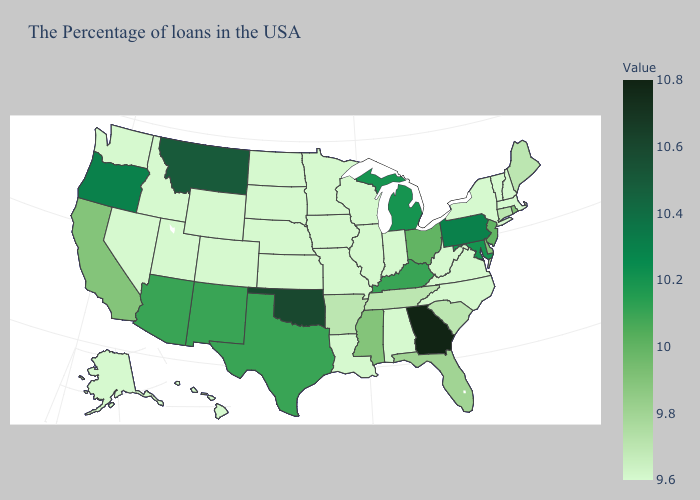Among the states that border West Virginia , does Virginia have the highest value?
Quick response, please. No. Among the states that border Washington , which have the lowest value?
Be succinct. Idaho. Among the states that border Nevada , which have the lowest value?
Concise answer only. Utah, Idaho. Which states have the highest value in the USA?
Give a very brief answer. Georgia. Among the states that border Georgia , does Florida have the highest value?
Be succinct. Yes. Which states have the lowest value in the South?
Write a very short answer. Virginia, North Carolina, West Virginia, Alabama, Louisiana. 